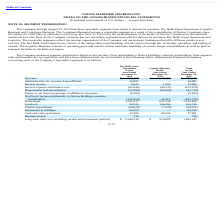According to Navios Maritime Holdings's financial document, How does the company measure segment performance? based on net income/ (loss) attributable to Navios Holdings common stockholders.. The document states: "The Company measures segment performance based on net income/ (loss) attributable to Navios Holdings common stockholders. Inter-segment..." Also, What was the revenue for logistics business for the year? According to the financial document, 228,271 (in thousands). The relevant text states: "Revenue $ 254,178 $ 228,271 $ 482,449..." Also, What was the total interest income for the year? According to the financial document, 10,662 (in thousands). The relevant text states: "Interest income 9,610 1,052 10,662..." Also, can you calculate: What was the difference in revenue between dry bulk vessel operations and logistics business? Based on the calculation: 254,178-228,271, the result is 25907 (in thousands). This is based on the information: "Revenue $ 254,178 $ 228,271 $ 482,449 Revenue $ 254,178 $ 228,271 $ 482,449..." The key data points involved are: 228,271, 254,178. Also, can you calculate: What was the difference in interest income between dry bulk vessel operations and logistics business? Based on the calculation: 9,610-1,052, the result is 8558 (in thousands). This is based on the information: "Interest income 9,610 1,052 10,662 Interest income 9,610 1,052 10,662..." The key data points involved are: 1,052, 9,610. Also, can you calculate: What was the difference in total goodwill and total investment in affiliates? Based on the calculation: 160,336-64,352, the result is 95984 (in thousands). This is based on the information: "Investment in affiliates 64,352 — 64,352 Goodwill 56,240 104,096 160,336..." The key data points involved are: 160,336, 64,352. 